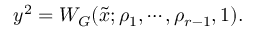<formula> <loc_0><loc_0><loc_500><loc_500>y ^ { 2 } = W _ { G } ( \tilde { x } ; \rho _ { 1 } , \cdots , \rho _ { r - 1 } , 1 ) .</formula> 